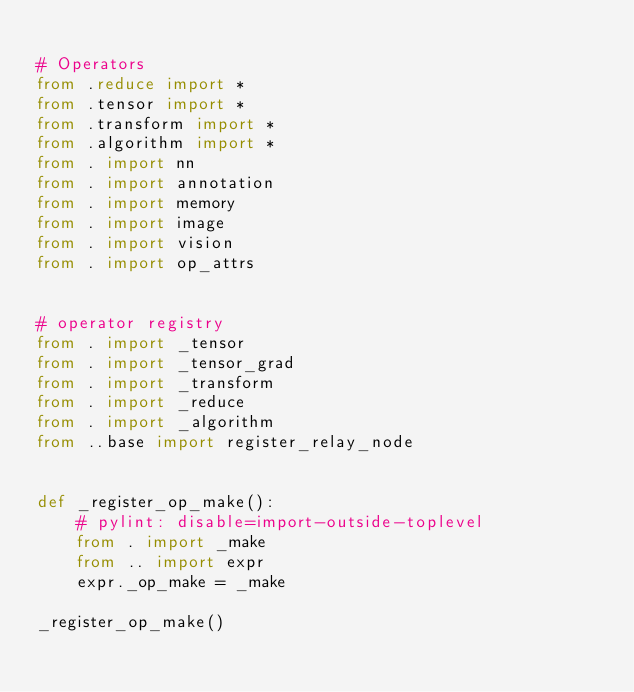Convert code to text. <code><loc_0><loc_0><loc_500><loc_500><_Python_>
# Operators
from .reduce import *
from .tensor import *
from .transform import *
from .algorithm import *
from . import nn
from . import annotation
from . import memory
from . import image
from . import vision
from . import op_attrs


# operator registry
from . import _tensor
from . import _tensor_grad
from . import _transform
from . import _reduce
from . import _algorithm
from ..base import register_relay_node


def _register_op_make():
    # pylint: disable=import-outside-toplevel
    from . import _make
    from .. import expr
    expr._op_make = _make

_register_op_make()
</code> 